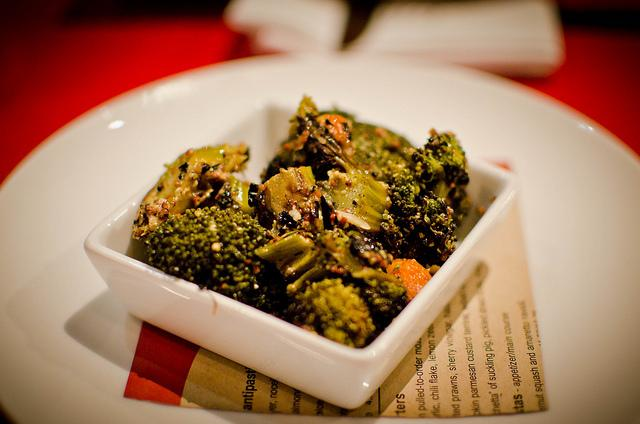What shape is the small plate?

Choices:
A) circle
B) octagon
C) square
D) hexagon square 